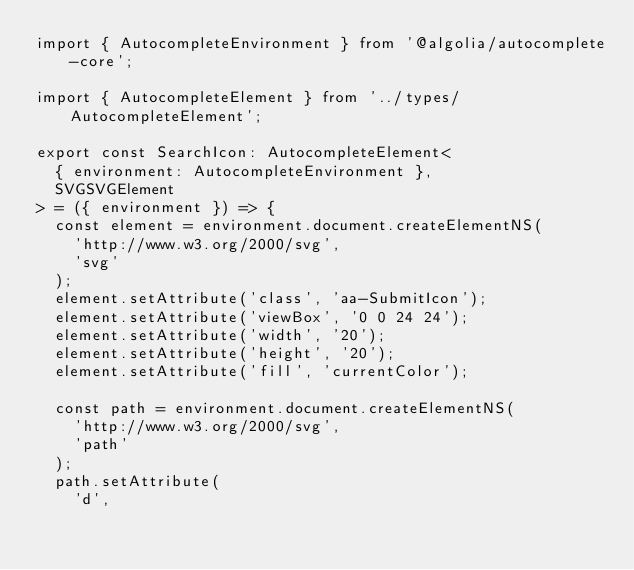<code> <loc_0><loc_0><loc_500><loc_500><_TypeScript_>import { AutocompleteEnvironment } from '@algolia/autocomplete-core';

import { AutocompleteElement } from '../types/AutocompleteElement';

export const SearchIcon: AutocompleteElement<
  { environment: AutocompleteEnvironment },
  SVGSVGElement
> = ({ environment }) => {
  const element = environment.document.createElementNS(
    'http://www.w3.org/2000/svg',
    'svg'
  );
  element.setAttribute('class', 'aa-SubmitIcon');
  element.setAttribute('viewBox', '0 0 24 24');
  element.setAttribute('width', '20');
  element.setAttribute('height', '20');
  element.setAttribute('fill', 'currentColor');

  const path = environment.document.createElementNS(
    'http://www.w3.org/2000/svg',
    'path'
  );
  path.setAttribute(
    'd',</code> 